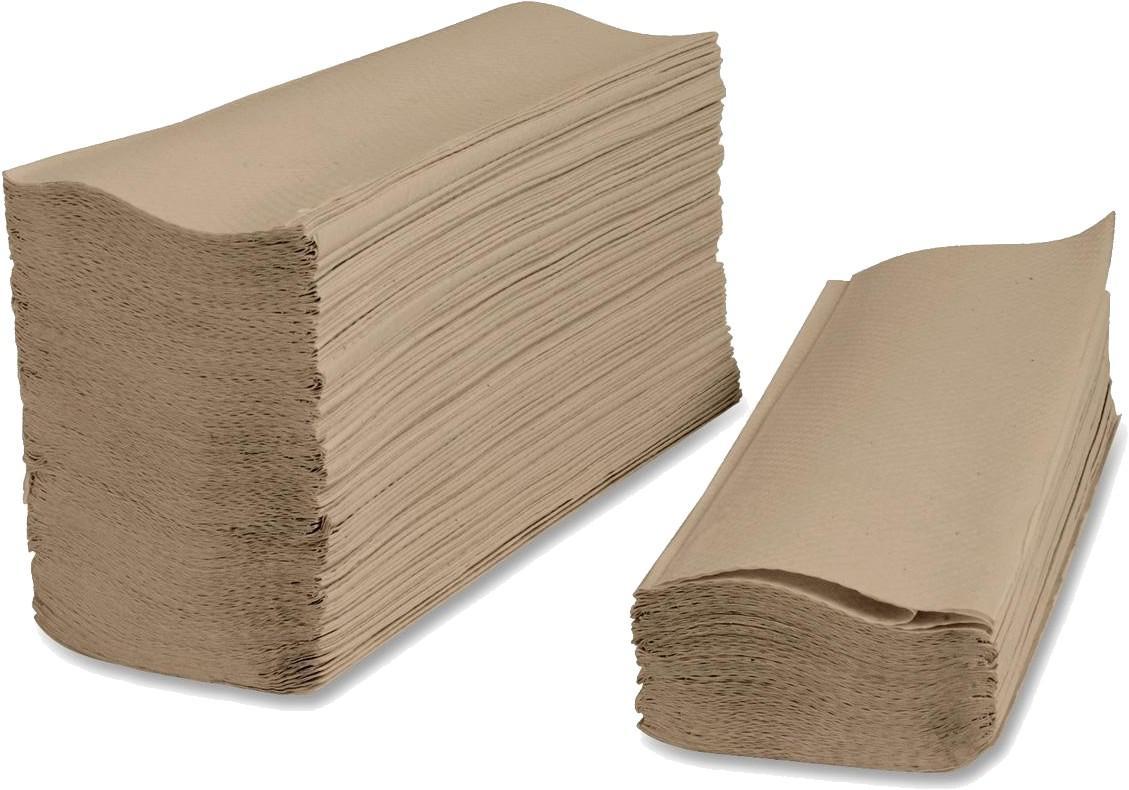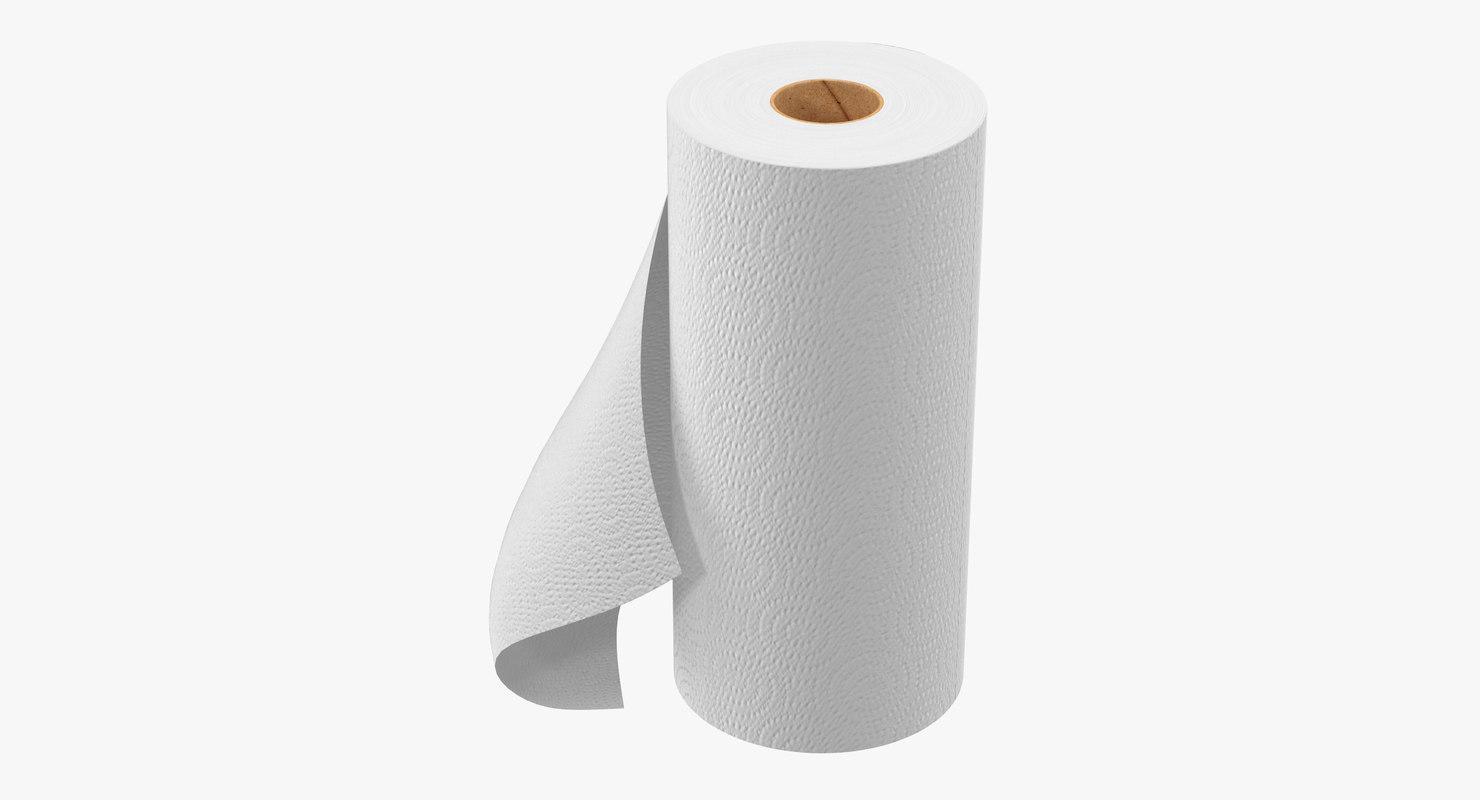The first image is the image on the left, the second image is the image on the right. Assess this claim about the two images: "One of the images features a white, upright roll of paper towels". Correct or not? Answer yes or no. Yes. 